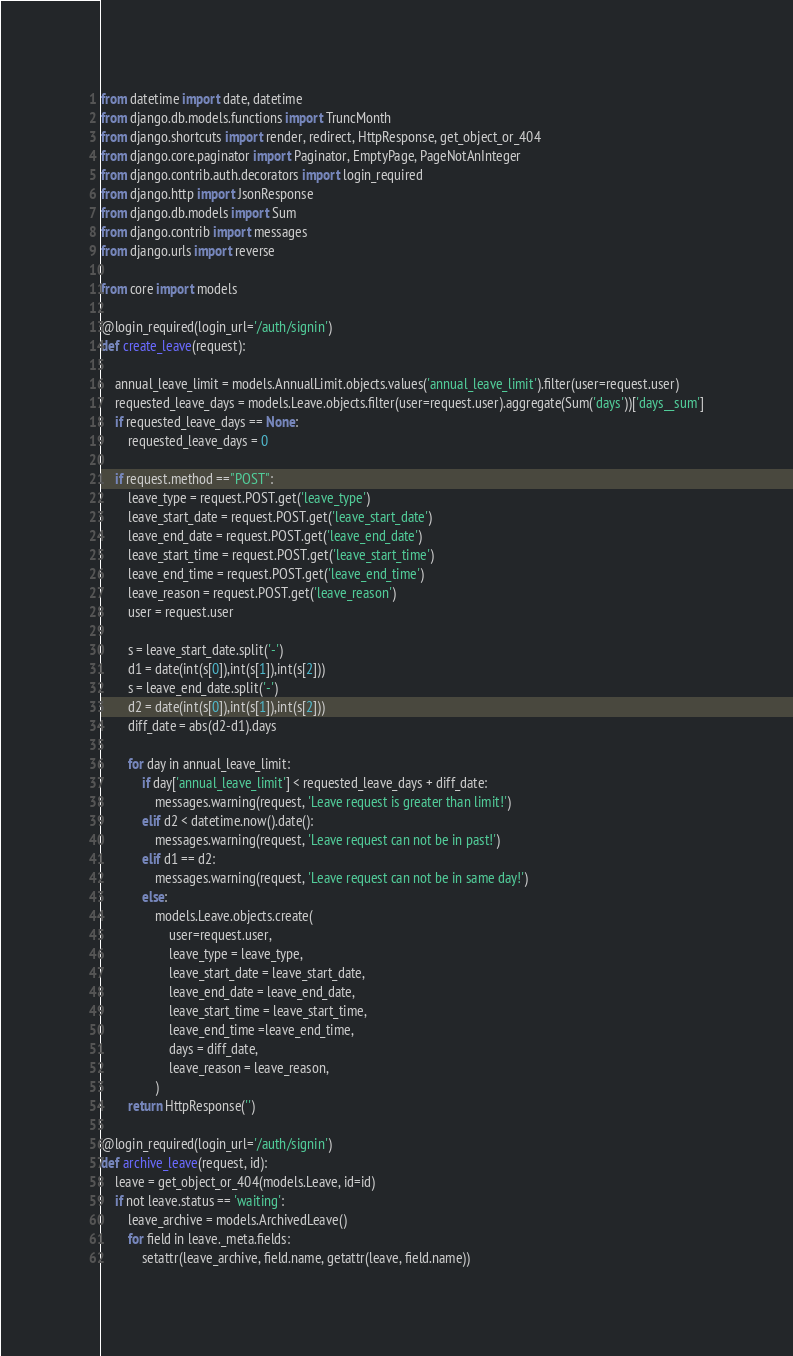Convert code to text. <code><loc_0><loc_0><loc_500><loc_500><_Python_>from datetime import date, datetime
from django.db.models.functions import TruncMonth
from django.shortcuts import render, redirect, HttpResponse, get_object_or_404
from django.core.paginator import Paginator, EmptyPage, PageNotAnInteger
from django.contrib.auth.decorators import login_required
from django.http import JsonResponse
from django.db.models import Sum
from django.contrib import messages
from django.urls import reverse

from core import models

@login_required(login_url='/auth/signin')
def create_leave(request):

    annual_leave_limit = models.AnnualLimit.objects.values('annual_leave_limit').filter(user=request.user)
    requested_leave_days = models.Leave.objects.filter(user=request.user).aggregate(Sum('days'))['days__sum']
    if requested_leave_days == None:
        requested_leave_days = 0

    if request.method =="POST":
        leave_type = request.POST.get('leave_type')
        leave_start_date = request.POST.get('leave_start_date')
        leave_end_date = request.POST.get('leave_end_date')
        leave_start_time = request.POST.get('leave_start_time')
        leave_end_time = request.POST.get('leave_end_time')
        leave_reason = request.POST.get('leave_reason')
        user = request.user

        s = leave_start_date.split('-')
        d1 = date(int(s[0]),int(s[1]),int(s[2]))
        s = leave_end_date.split('-')
        d2 = date(int(s[0]),int(s[1]),int(s[2]))    
        diff_date = abs(d2-d1).days
        
        for day in annual_leave_limit:
            if day['annual_leave_limit'] < requested_leave_days + diff_date:
                messages.warning(request, 'Leave request is greater than limit!')
            elif d2 < datetime.now().date():
                messages.warning(request, 'Leave request can not be in past!')
            elif d1 == d2:
                messages.warning(request, 'Leave request can not be in same day!')
            else:
                models.Leave.objects.create(
                    user=request.user,
                    leave_type = leave_type,
                    leave_start_date = leave_start_date,
                    leave_end_date = leave_end_date,
                    leave_start_time = leave_start_time,
                    leave_end_time =leave_end_time,
                    days = diff_date,
                    leave_reason = leave_reason,
                ) 
        return HttpResponse('')

@login_required(login_url='/auth/signin')
def archive_leave(request, id):
    leave = get_object_or_404(models.Leave, id=id)
    if not leave.status == 'waiting':
        leave_archive = models.ArchivedLeave()
        for field in leave._meta.fields:
            setattr(leave_archive, field.name, getattr(leave, field.name))</code> 